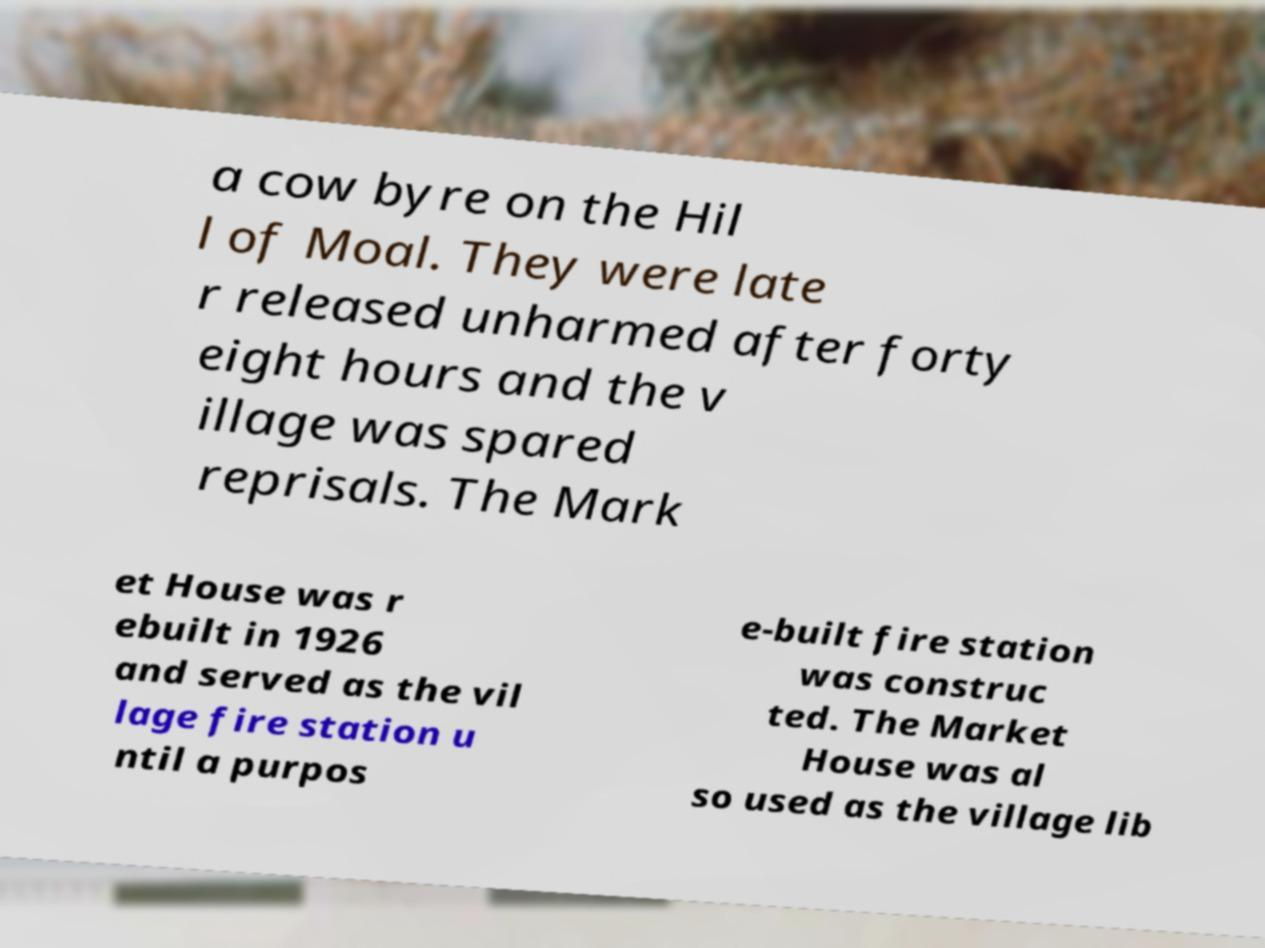There's text embedded in this image that I need extracted. Can you transcribe it verbatim? a cow byre on the Hil l of Moal. They were late r released unharmed after forty eight hours and the v illage was spared reprisals. The Mark et House was r ebuilt in 1926 and served as the vil lage fire station u ntil a purpos e-built fire station was construc ted. The Market House was al so used as the village lib 